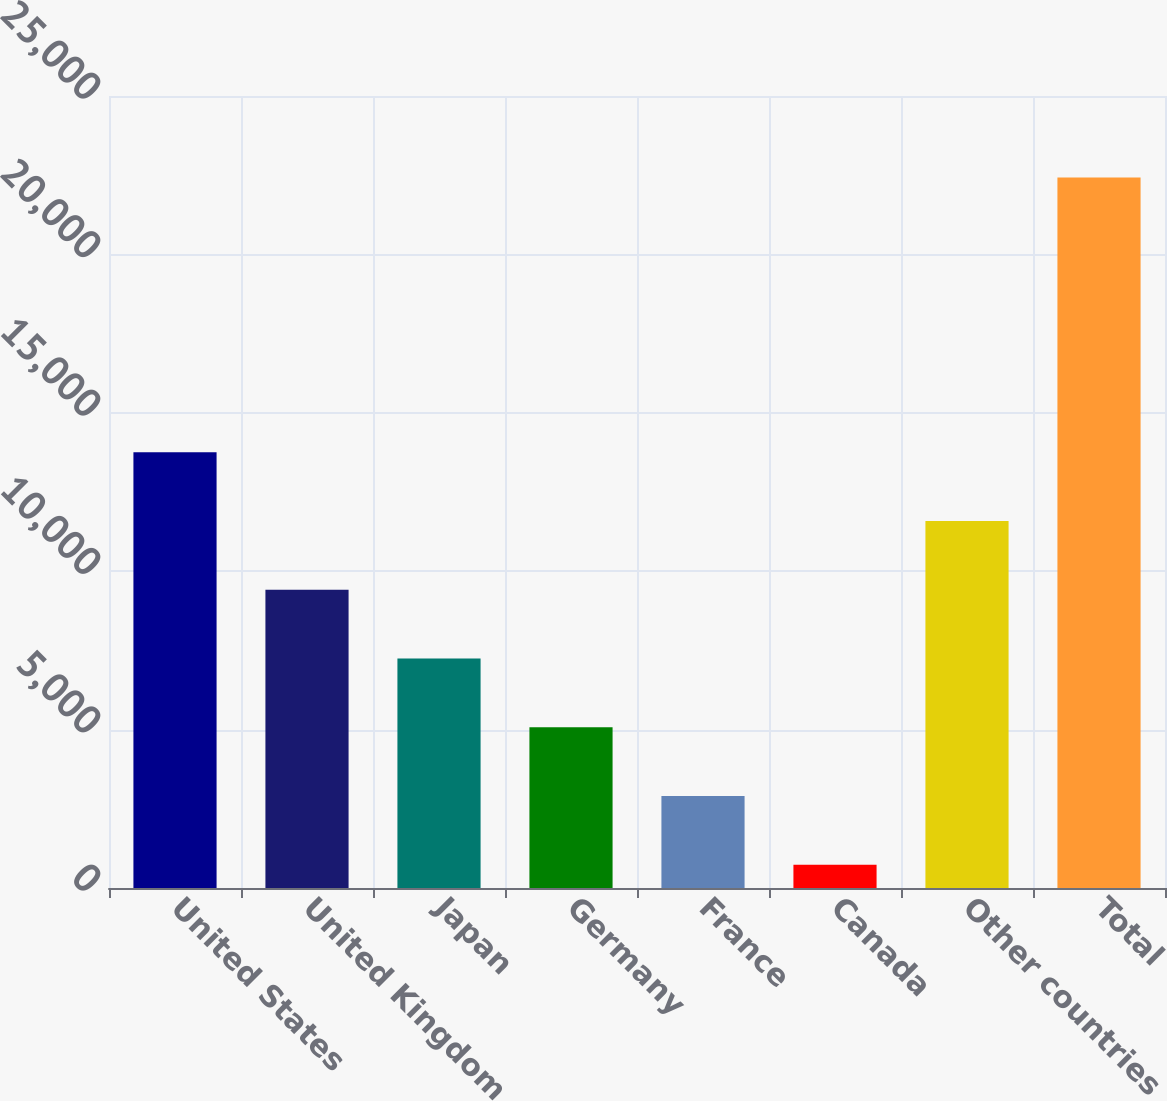Convert chart. <chart><loc_0><loc_0><loc_500><loc_500><bar_chart><fcel>United States<fcel>United Kingdom<fcel>Japan<fcel>Germany<fcel>France<fcel>Canada<fcel>Other countries<fcel>Total<nl><fcel>13752.8<fcel>9414.2<fcel>7244.9<fcel>5075.6<fcel>2906.3<fcel>737<fcel>11583.5<fcel>22430<nl></chart> 